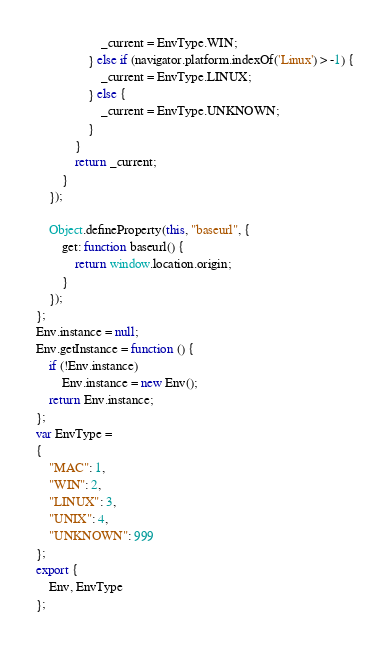Convert code to text. <code><loc_0><loc_0><loc_500><loc_500><_JavaScript_>                    _current = EnvType.WIN;
                } else if (navigator.platform.indexOf('Linux') > -1) {
                    _current = EnvType.LINUX;
                } else {
                    _current = EnvType.UNKNOWN;
                }
            }
            return _current;
        }
    });
    
    Object.defineProperty(this, "baseurl", {
        get: function baseurl() {
            return window.location.origin;
        }
    });
};
Env.instance = null;
Env.getInstance = function () {
    if (!Env.instance)
        Env.instance = new Env();
    return Env.instance;
};
var EnvType =
{
    "MAC": 1,
    "WIN": 2,
    "LINUX": 3,
    "UNIX": 4,
    "UNKNOWN": 999
};
export {
    Env, EnvType
};</code> 